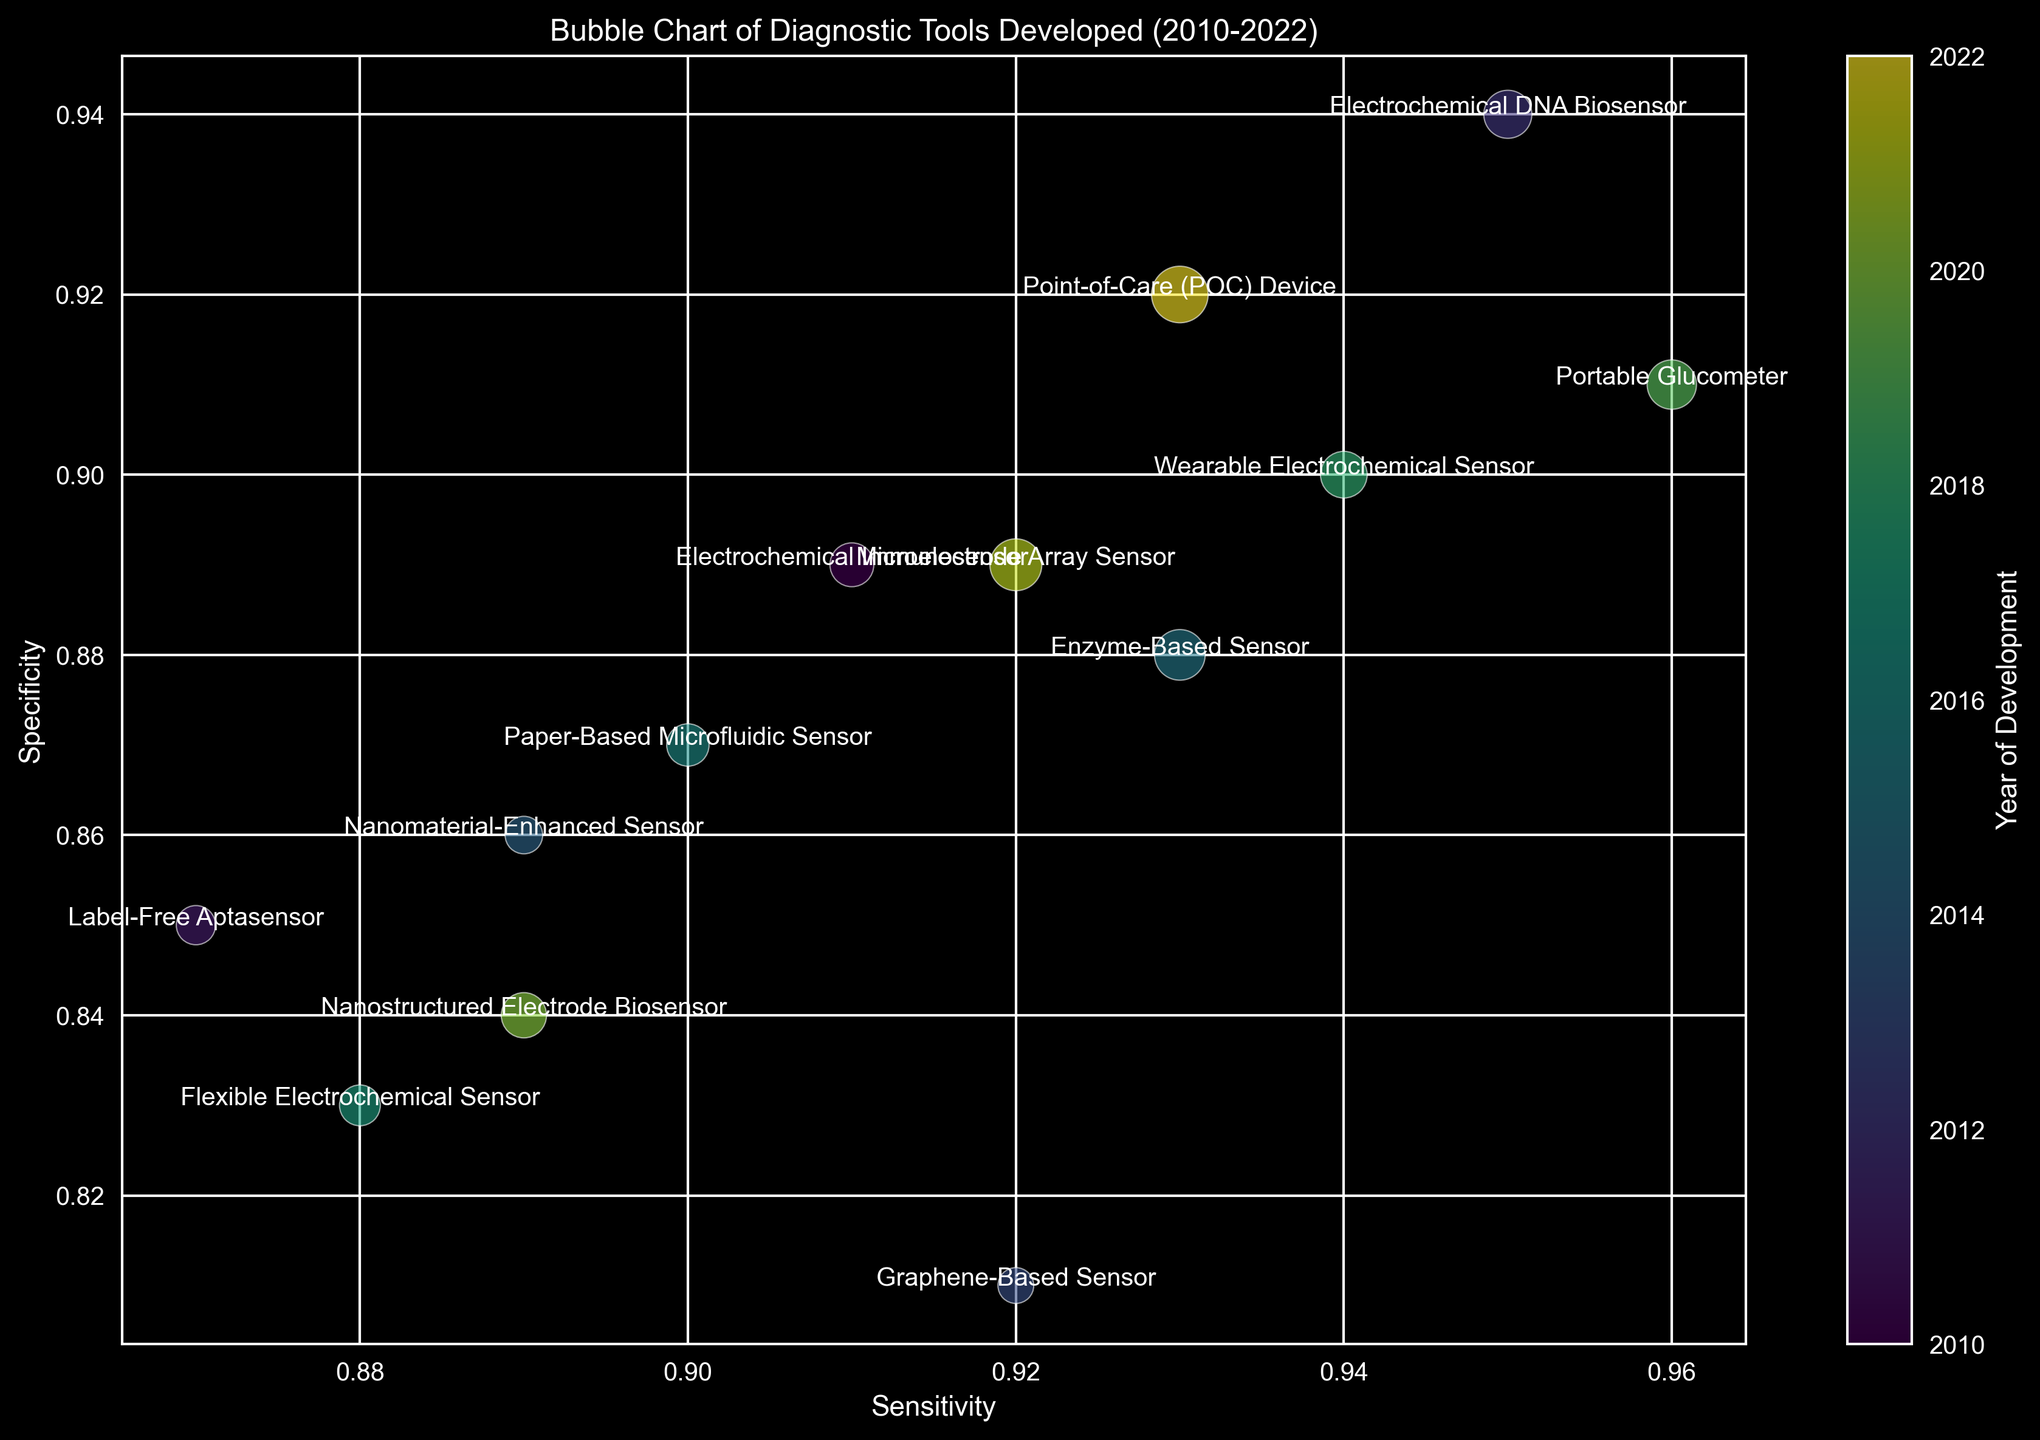What diagnostic tool has the highest sensitivity? We look at the Sensitivity axis and identify the tool with the highest value. The Portable Glucometer developed in 2019 has the highest sensitivity of 0.96.
Answer: Portable Glucometer Which years correspond to the tools with sensitivity greater than 0.9 and specificity greater than 0.9? We filter out the data points with sensitivity > 0.9 and specificity > 0.9. The tools meeting the criteria are Electrochemical DNA Biosensor (2012), Wearable Electrochemical Sensor (2018), Portable Glucometer (2019), and Point-of-Care (POC) Device (2022).
Answer: 2012, 2018, 2019, 2022 Compare the sensitivity and specificity of the Electrochemical Immunosensor and the Microelectrode Array Sensor. Which one has a higher sensitivity and which one has a higher specificity? Sensitivity of Electrochemical Immunosensor is 0.91 and Microelectrode Array Sensor is 0.92. Specificity of Electrochemical Immunosensor is 0.89 and Microelectrode Array Sensor is 0.89. So Microelectrode Array Sensor has higher sensitivity, and they have equal specificity.
Answer: Microelectrode Array Sensor has higher sensitivity; both have equal specificity How many diagnostic tools were developed in or after 2015? We count the number of bubbles corresponding to the years 2015 to 2022. The tools developed after 2015 are Enzyme-Based Sensor (2015), Paper-Based Microfluidic Sensor (2016), Flexible Electrochemical Sensor (2017), Wearable Electrochemical Sensor (2018), Portable Glucometer (2019), Nanostructured Electrode Biosensor (2020), Microelectrode Array Sensor (2021), and Point-of-Care (POC) Device (2022). Thus, there are 8 tools.
Answer: 8 Which tool has the largest bubble size and in which year was it developed? The bubble size represents the number of studies, and the largest bubble corresponds to the Point-of-Care (POC) Device developed in 2022 with 25 studies.
Answer: Point-of-Care (POC) Device, 2022 What trend do you observe in the development of diagnostic tools from 2010 to 2022 in terms of number of studies? By examining the bubble sizes along the horizontal axis (year), we observe that the number of studies tends to increase over the years, with the largest bubbles appearing in the later years.
Answer: Increase in number of studies Compare the sensitivity and specificity of tools using Electrochemical Impedance Spectroscopy (EIS) technique. For tools using EIS, the Label-Free Aptasensor has Sensitivity=0.87, Specificity=0.85 and Wearable Electrochemical Sensor has Sensitivity=0.94, Specificity=0.90. The Wearable Electrochemical Sensor has higher sensitivity and specificity than the Label-Free Aptasensor.
Answer: Wearable Electrochemical Sensor has higher sensitivity and specificity 